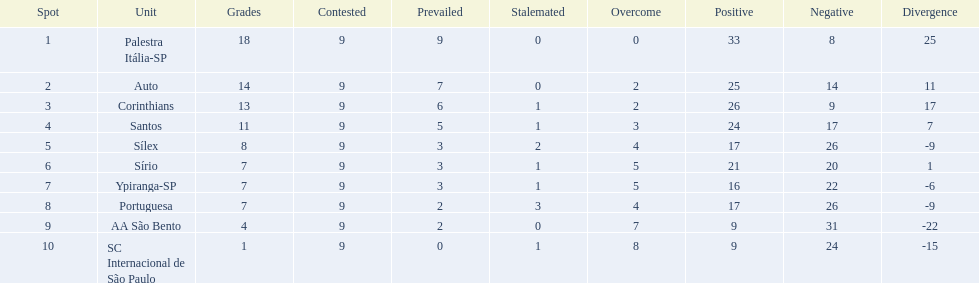Which team was the only team that was undefeated? Palestra Itália-SP. 